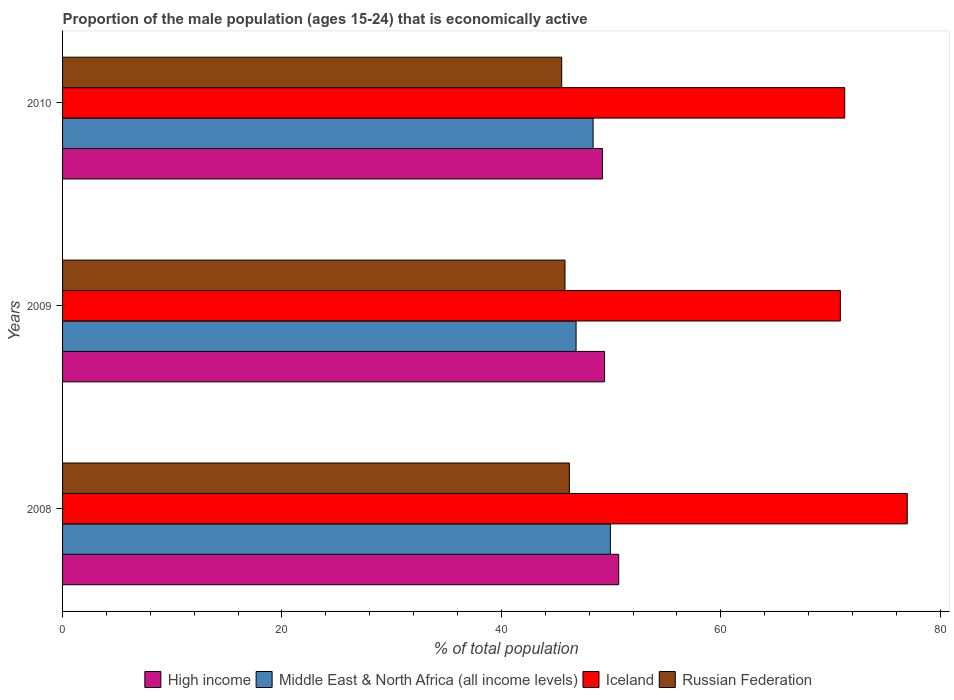How many different coloured bars are there?
Make the answer very short. 4. What is the label of the 2nd group of bars from the top?
Offer a terse response. 2009. In how many cases, is the number of bars for a given year not equal to the number of legend labels?
Your answer should be very brief. 0. What is the proportion of the male population that is economically active in Russian Federation in 2008?
Offer a terse response. 46.2. Across all years, what is the maximum proportion of the male population that is economically active in High income?
Offer a very short reply. 50.7. Across all years, what is the minimum proportion of the male population that is economically active in Russian Federation?
Your answer should be very brief. 45.5. In which year was the proportion of the male population that is economically active in Iceland maximum?
Your answer should be very brief. 2008. In which year was the proportion of the male population that is economically active in Middle East & North Africa (all income levels) minimum?
Give a very brief answer. 2009. What is the total proportion of the male population that is economically active in High income in the graph?
Your answer should be compact. 149.32. What is the difference between the proportion of the male population that is economically active in Middle East & North Africa (all income levels) in 2009 and that in 2010?
Provide a succinct answer. -1.55. What is the difference between the proportion of the male population that is economically active in Iceland in 2009 and the proportion of the male population that is economically active in Middle East & North Africa (all income levels) in 2008?
Provide a succinct answer. 20.96. What is the average proportion of the male population that is economically active in High income per year?
Offer a very short reply. 49.77. In the year 2009, what is the difference between the proportion of the male population that is economically active in Iceland and proportion of the male population that is economically active in Middle East & North Africa (all income levels)?
Offer a very short reply. 24.09. In how many years, is the proportion of the male population that is economically active in Middle East & North Africa (all income levels) greater than 68 %?
Make the answer very short. 0. What is the ratio of the proportion of the male population that is economically active in Russian Federation in 2008 to that in 2009?
Offer a terse response. 1.01. Is the proportion of the male population that is economically active in Middle East & North Africa (all income levels) in 2008 less than that in 2009?
Provide a short and direct response. No. What is the difference between the highest and the second highest proportion of the male population that is economically active in Iceland?
Keep it short and to the point. 5.7. What is the difference between the highest and the lowest proportion of the male population that is economically active in Iceland?
Your answer should be compact. 6.1. Is the sum of the proportion of the male population that is economically active in High income in 2008 and 2010 greater than the maximum proportion of the male population that is economically active in Iceland across all years?
Offer a terse response. Yes. What does the 4th bar from the top in 2010 represents?
Your answer should be very brief. High income. What does the 2nd bar from the bottom in 2008 represents?
Offer a terse response. Middle East & North Africa (all income levels). Is it the case that in every year, the sum of the proportion of the male population that is economically active in High income and proportion of the male population that is economically active in Middle East & North Africa (all income levels) is greater than the proportion of the male population that is economically active in Iceland?
Your response must be concise. Yes. How many years are there in the graph?
Your response must be concise. 3. Does the graph contain grids?
Offer a very short reply. No. How many legend labels are there?
Make the answer very short. 4. What is the title of the graph?
Give a very brief answer. Proportion of the male population (ages 15-24) that is economically active. What is the label or title of the X-axis?
Your response must be concise. % of total population. What is the % of total population in High income in 2008?
Give a very brief answer. 50.7. What is the % of total population in Middle East & North Africa (all income levels) in 2008?
Make the answer very short. 49.94. What is the % of total population in Russian Federation in 2008?
Your answer should be very brief. 46.2. What is the % of total population in High income in 2009?
Offer a very short reply. 49.41. What is the % of total population in Middle East & North Africa (all income levels) in 2009?
Your response must be concise. 46.81. What is the % of total population of Iceland in 2009?
Give a very brief answer. 70.9. What is the % of total population of Russian Federation in 2009?
Provide a short and direct response. 45.8. What is the % of total population of High income in 2010?
Give a very brief answer. 49.21. What is the % of total population of Middle East & North Africa (all income levels) in 2010?
Offer a very short reply. 48.36. What is the % of total population of Iceland in 2010?
Keep it short and to the point. 71.3. What is the % of total population in Russian Federation in 2010?
Give a very brief answer. 45.5. Across all years, what is the maximum % of total population in High income?
Provide a succinct answer. 50.7. Across all years, what is the maximum % of total population of Middle East & North Africa (all income levels)?
Your answer should be very brief. 49.94. Across all years, what is the maximum % of total population in Iceland?
Your answer should be compact. 77. Across all years, what is the maximum % of total population of Russian Federation?
Make the answer very short. 46.2. Across all years, what is the minimum % of total population in High income?
Your response must be concise. 49.21. Across all years, what is the minimum % of total population of Middle East & North Africa (all income levels)?
Offer a very short reply. 46.81. Across all years, what is the minimum % of total population of Iceland?
Keep it short and to the point. 70.9. Across all years, what is the minimum % of total population in Russian Federation?
Provide a succinct answer. 45.5. What is the total % of total population of High income in the graph?
Offer a terse response. 149.32. What is the total % of total population of Middle East & North Africa (all income levels) in the graph?
Make the answer very short. 145.11. What is the total % of total population in Iceland in the graph?
Make the answer very short. 219.2. What is the total % of total population in Russian Federation in the graph?
Provide a short and direct response. 137.5. What is the difference between the % of total population in High income in 2008 and that in 2009?
Your answer should be compact. 1.29. What is the difference between the % of total population in Middle East & North Africa (all income levels) in 2008 and that in 2009?
Offer a terse response. 3.13. What is the difference between the % of total population in Iceland in 2008 and that in 2009?
Keep it short and to the point. 6.1. What is the difference between the % of total population in Russian Federation in 2008 and that in 2009?
Your answer should be very brief. 0.4. What is the difference between the % of total population in High income in 2008 and that in 2010?
Ensure brevity in your answer.  1.48. What is the difference between the % of total population in Middle East & North Africa (all income levels) in 2008 and that in 2010?
Offer a very short reply. 1.57. What is the difference between the % of total population of Iceland in 2008 and that in 2010?
Ensure brevity in your answer.  5.7. What is the difference between the % of total population of High income in 2009 and that in 2010?
Your answer should be compact. 0.2. What is the difference between the % of total population in Middle East & North Africa (all income levels) in 2009 and that in 2010?
Offer a very short reply. -1.55. What is the difference between the % of total population in Iceland in 2009 and that in 2010?
Ensure brevity in your answer.  -0.4. What is the difference between the % of total population in High income in 2008 and the % of total population in Middle East & North Africa (all income levels) in 2009?
Provide a short and direct response. 3.89. What is the difference between the % of total population of High income in 2008 and the % of total population of Iceland in 2009?
Your answer should be compact. -20.2. What is the difference between the % of total population of High income in 2008 and the % of total population of Russian Federation in 2009?
Ensure brevity in your answer.  4.9. What is the difference between the % of total population in Middle East & North Africa (all income levels) in 2008 and the % of total population in Iceland in 2009?
Offer a very short reply. -20.96. What is the difference between the % of total population in Middle East & North Africa (all income levels) in 2008 and the % of total population in Russian Federation in 2009?
Your response must be concise. 4.14. What is the difference between the % of total population of Iceland in 2008 and the % of total population of Russian Federation in 2009?
Give a very brief answer. 31.2. What is the difference between the % of total population in High income in 2008 and the % of total population in Middle East & North Africa (all income levels) in 2010?
Offer a very short reply. 2.33. What is the difference between the % of total population in High income in 2008 and the % of total population in Iceland in 2010?
Provide a succinct answer. -20.6. What is the difference between the % of total population of High income in 2008 and the % of total population of Russian Federation in 2010?
Your answer should be very brief. 5.2. What is the difference between the % of total population in Middle East & North Africa (all income levels) in 2008 and the % of total population in Iceland in 2010?
Give a very brief answer. -21.36. What is the difference between the % of total population in Middle East & North Africa (all income levels) in 2008 and the % of total population in Russian Federation in 2010?
Offer a terse response. 4.44. What is the difference between the % of total population of Iceland in 2008 and the % of total population of Russian Federation in 2010?
Make the answer very short. 31.5. What is the difference between the % of total population in High income in 2009 and the % of total population in Middle East & North Africa (all income levels) in 2010?
Ensure brevity in your answer.  1.05. What is the difference between the % of total population of High income in 2009 and the % of total population of Iceland in 2010?
Your response must be concise. -21.89. What is the difference between the % of total population in High income in 2009 and the % of total population in Russian Federation in 2010?
Provide a succinct answer. 3.91. What is the difference between the % of total population of Middle East & North Africa (all income levels) in 2009 and the % of total population of Iceland in 2010?
Your response must be concise. -24.49. What is the difference between the % of total population of Middle East & North Africa (all income levels) in 2009 and the % of total population of Russian Federation in 2010?
Provide a succinct answer. 1.31. What is the difference between the % of total population in Iceland in 2009 and the % of total population in Russian Federation in 2010?
Provide a short and direct response. 25.4. What is the average % of total population in High income per year?
Your answer should be compact. 49.77. What is the average % of total population in Middle East & North Africa (all income levels) per year?
Make the answer very short. 48.37. What is the average % of total population of Iceland per year?
Ensure brevity in your answer.  73.07. What is the average % of total population of Russian Federation per year?
Give a very brief answer. 45.83. In the year 2008, what is the difference between the % of total population in High income and % of total population in Middle East & North Africa (all income levels)?
Provide a succinct answer. 0.76. In the year 2008, what is the difference between the % of total population in High income and % of total population in Iceland?
Your answer should be compact. -26.3. In the year 2008, what is the difference between the % of total population of High income and % of total population of Russian Federation?
Your answer should be very brief. 4.5. In the year 2008, what is the difference between the % of total population in Middle East & North Africa (all income levels) and % of total population in Iceland?
Ensure brevity in your answer.  -27.06. In the year 2008, what is the difference between the % of total population in Middle East & North Africa (all income levels) and % of total population in Russian Federation?
Your answer should be compact. 3.74. In the year 2008, what is the difference between the % of total population in Iceland and % of total population in Russian Federation?
Provide a succinct answer. 30.8. In the year 2009, what is the difference between the % of total population of High income and % of total population of Middle East & North Africa (all income levels)?
Your response must be concise. 2.6. In the year 2009, what is the difference between the % of total population in High income and % of total population in Iceland?
Offer a terse response. -21.49. In the year 2009, what is the difference between the % of total population of High income and % of total population of Russian Federation?
Provide a short and direct response. 3.61. In the year 2009, what is the difference between the % of total population of Middle East & North Africa (all income levels) and % of total population of Iceland?
Make the answer very short. -24.09. In the year 2009, what is the difference between the % of total population of Middle East & North Africa (all income levels) and % of total population of Russian Federation?
Give a very brief answer. 1.01. In the year 2009, what is the difference between the % of total population in Iceland and % of total population in Russian Federation?
Keep it short and to the point. 25.1. In the year 2010, what is the difference between the % of total population of High income and % of total population of Middle East & North Africa (all income levels)?
Your answer should be compact. 0.85. In the year 2010, what is the difference between the % of total population in High income and % of total population in Iceland?
Provide a short and direct response. -22.09. In the year 2010, what is the difference between the % of total population of High income and % of total population of Russian Federation?
Offer a terse response. 3.71. In the year 2010, what is the difference between the % of total population of Middle East & North Africa (all income levels) and % of total population of Iceland?
Provide a succinct answer. -22.94. In the year 2010, what is the difference between the % of total population of Middle East & North Africa (all income levels) and % of total population of Russian Federation?
Give a very brief answer. 2.86. In the year 2010, what is the difference between the % of total population of Iceland and % of total population of Russian Federation?
Ensure brevity in your answer.  25.8. What is the ratio of the % of total population in High income in 2008 to that in 2009?
Ensure brevity in your answer.  1.03. What is the ratio of the % of total population of Middle East & North Africa (all income levels) in 2008 to that in 2009?
Your answer should be compact. 1.07. What is the ratio of the % of total population of Iceland in 2008 to that in 2009?
Make the answer very short. 1.09. What is the ratio of the % of total population of Russian Federation in 2008 to that in 2009?
Make the answer very short. 1.01. What is the ratio of the % of total population in High income in 2008 to that in 2010?
Your answer should be very brief. 1.03. What is the ratio of the % of total population in Middle East & North Africa (all income levels) in 2008 to that in 2010?
Offer a very short reply. 1.03. What is the ratio of the % of total population in Iceland in 2008 to that in 2010?
Your response must be concise. 1.08. What is the ratio of the % of total population in Russian Federation in 2008 to that in 2010?
Offer a terse response. 1.02. What is the ratio of the % of total population of High income in 2009 to that in 2010?
Provide a succinct answer. 1. What is the ratio of the % of total population of Middle East & North Africa (all income levels) in 2009 to that in 2010?
Make the answer very short. 0.97. What is the ratio of the % of total population in Iceland in 2009 to that in 2010?
Your response must be concise. 0.99. What is the ratio of the % of total population in Russian Federation in 2009 to that in 2010?
Offer a very short reply. 1.01. What is the difference between the highest and the second highest % of total population in High income?
Your answer should be compact. 1.29. What is the difference between the highest and the second highest % of total population in Middle East & North Africa (all income levels)?
Provide a short and direct response. 1.57. What is the difference between the highest and the lowest % of total population of High income?
Give a very brief answer. 1.48. What is the difference between the highest and the lowest % of total population of Middle East & North Africa (all income levels)?
Make the answer very short. 3.13. What is the difference between the highest and the lowest % of total population of Iceland?
Provide a succinct answer. 6.1. What is the difference between the highest and the lowest % of total population of Russian Federation?
Provide a succinct answer. 0.7. 